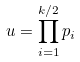<formula> <loc_0><loc_0><loc_500><loc_500>u = \prod _ { i = 1 } ^ { k / 2 } p _ { i }</formula> 